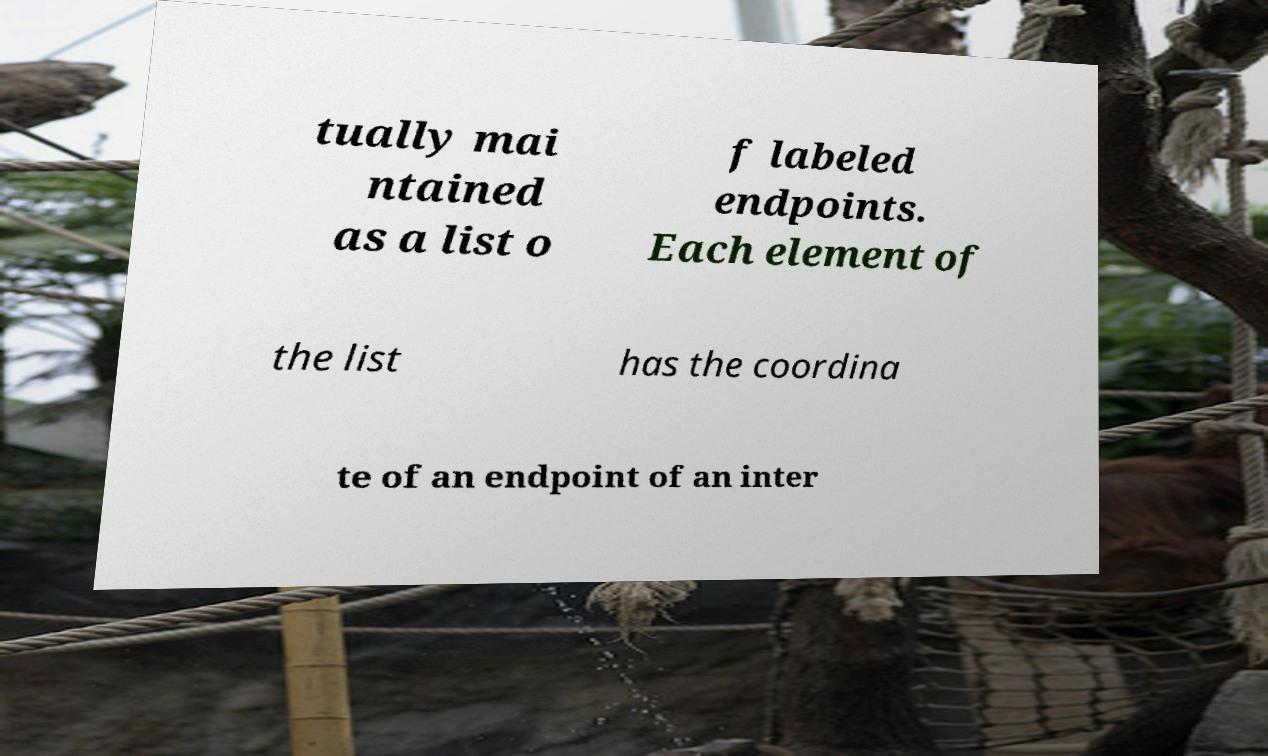For documentation purposes, I need the text within this image transcribed. Could you provide that? tually mai ntained as a list o f labeled endpoints. Each element of the list has the coordina te of an endpoint of an inter 